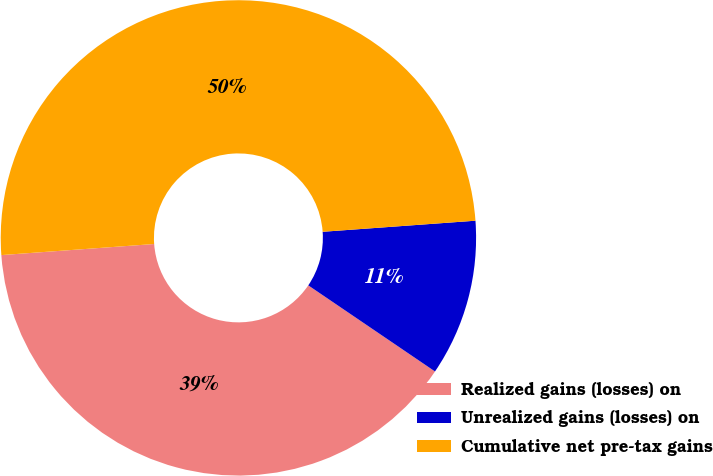Convert chart. <chart><loc_0><loc_0><loc_500><loc_500><pie_chart><fcel>Realized gains (losses) on<fcel>Unrealized gains (losses) on<fcel>Cumulative net pre-tax gains<nl><fcel>39.35%<fcel>10.65%<fcel>50.0%<nl></chart> 